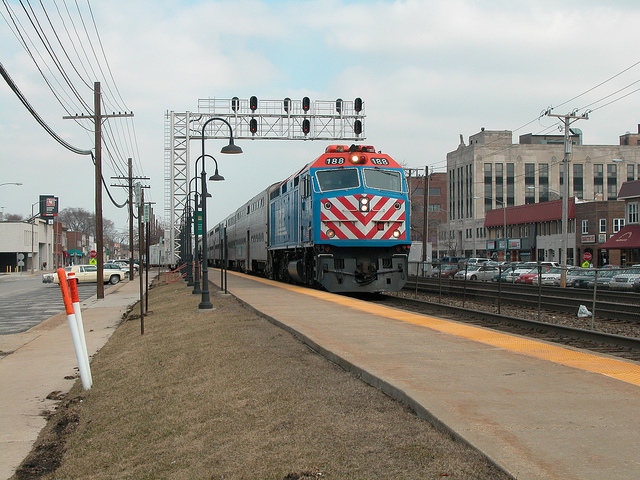Extract all visible text content from this image. 180 188 